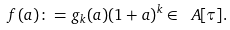<formula> <loc_0><loc_0><loc_500><loc_500>f ( a ) \colon = g _ { k } ( a ) ( 1 + a ) ^ { k } \in \ A [ \tau ] .</formula> 